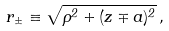Convert formula to latex. <formula><loc_0><loc_0><loc_500><loc_500>r _ { \pm } \equiv \sqrt { \rho ^ { 2 } + ( z \mp a ) ^ { 2 } } \, ,</formula> 